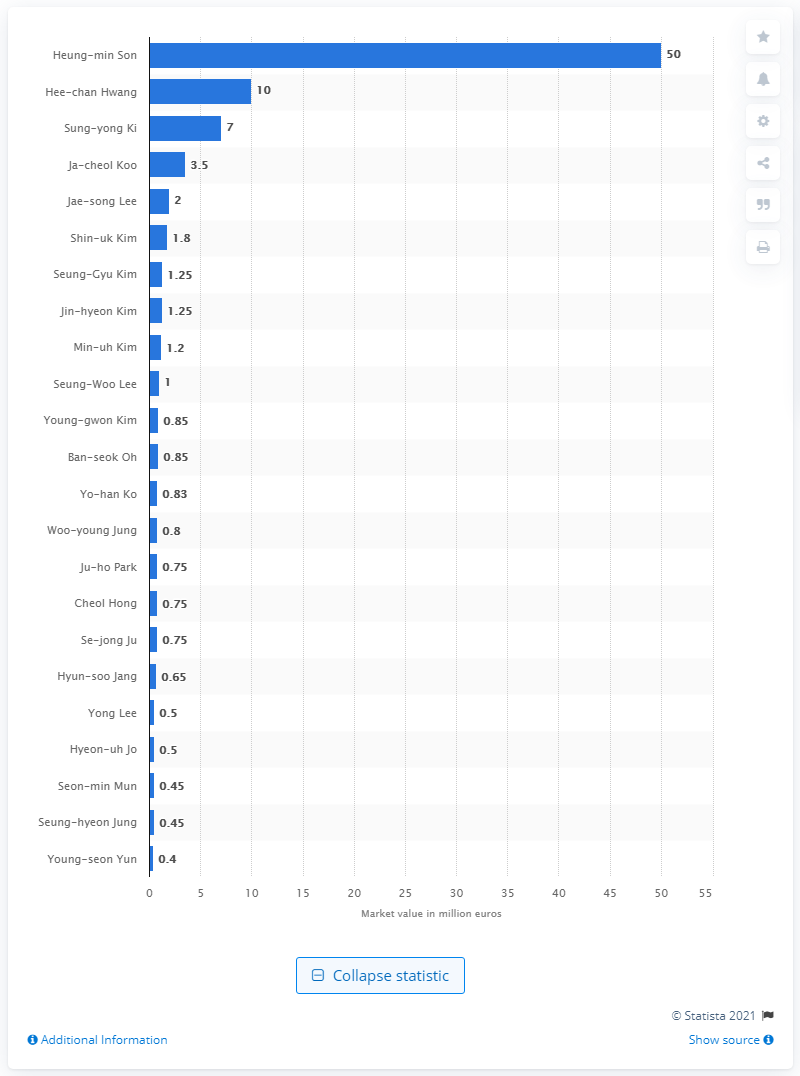Indicate a few pertinent items in this graphic. What was the market value of Son? It was estimated to be 50.. Heung-min Son was the most valuable player at the 2018 FIFA World Cup. 